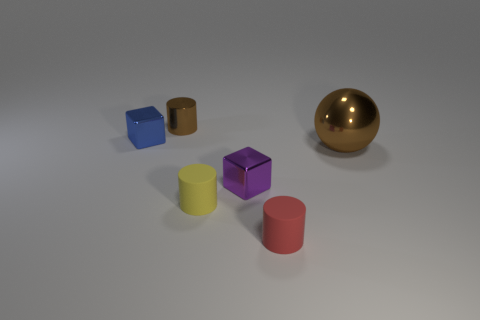Add 3 red cylinders. How many objects exist? 9 Subtract all balls. How many objects are left? 5 Subtract all purple objects. Subtract all small rubber cylinders. How many objects are left? 3 Add 6 small brown things. How many small brown things are left? 7 Add 6 small green metallic balls. How many small green metallic balls exist? 6 Subtract 0 brown blocks. How many objects are left? 6 